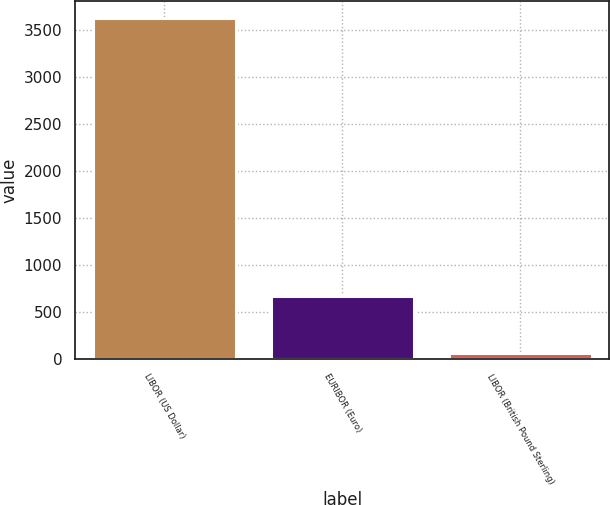Convert chart. <chart><loc_0><loc_0><loc_500><loc_500><bar_chart><fcel>LIBOR (US Dollar)<fcel>EURIBOR (Euro)<fcel>LIBOR (British Pound Sterling)<nl><fcel>3628<fcel>673<fcel>58<nl></chart> 